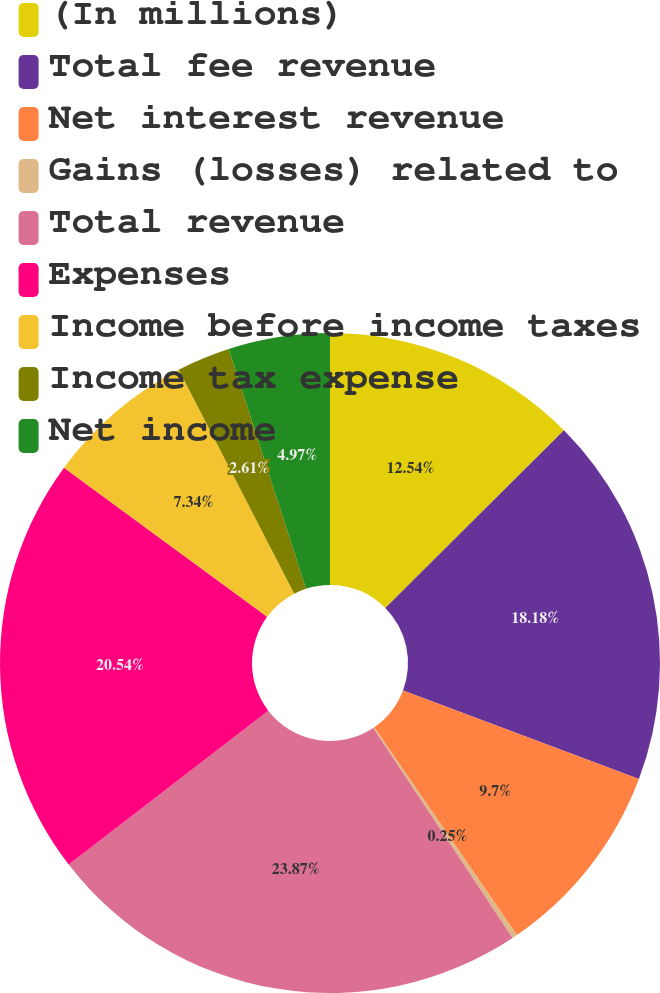Convert chart to OTSL. <chart><loc_0><loc_0><loc_500><loc_500><pie_chart><fcel>(In millions)<fcel>Total fee revenue<fcel>Net interest revenue<fcel>Gains (losses) related to<fcel>Total revenue<fcel>Expenses<fcel>Income before income taxes<fcel>Income tax expense<fcel>Net income<nl><fcel>12.54%<fcel>18.18%<fcel>9.7%<fcel>0.25%<fcel>23.87%<fcel>20.54%<fcel>7.34%<fcel>2.61%<fcel>4.97%<nl></chart> 